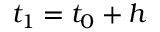<formula> <loc_0><loc_0><loc_500><loc_500>t _ { 1 } = t _ { 0 } + h</formula> 